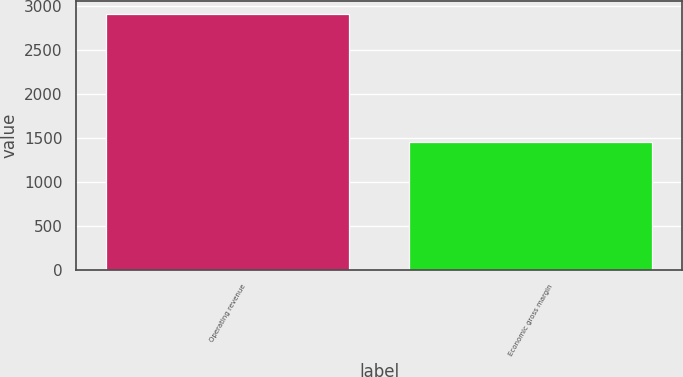<chart> <loc_0><loc_0><loc_500><loc_500><bar_chart><fcel>Operating revenue<fcel>Economic gross margin<nl><fcel>2909<fcel>1458<nl></chart> 